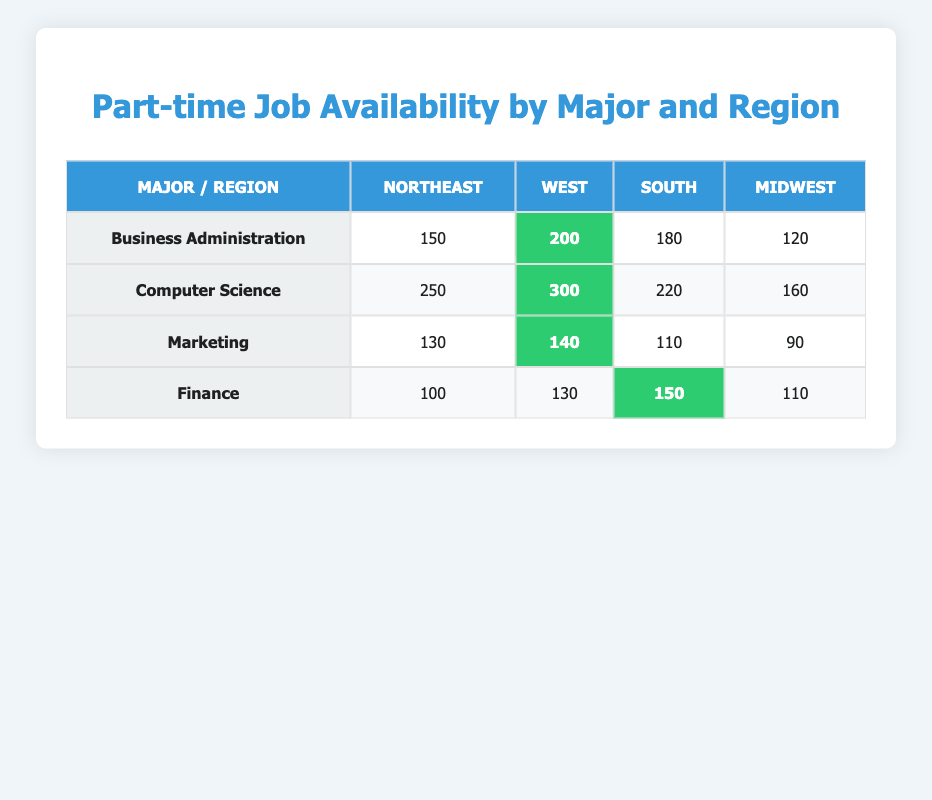What is the number of part-time jobs available for Business Administration students in the West region? The table shows that for Business Administration students in the West region, the number of part-time jobs available is highlighted as 200.
Answer: 200 Which major has the highest availability of part-time jobs in the Northeast region? By examining the Northeast column, Computer Science has the highest number of part-time jobs available, with a total of 250 jobs compared to 150 for Business Administration, 130 for Marketing, and 100 for Finance.
Answer: Computer Science What is the total number of part-time jobs available for Marketing students across all regions? The total can be calculated as follows: Northeast (130) + West (140) + South (110) + Midwest (90) = 130 + 140 + 110 + 90 = 470.
Answer: 470 Are there more part-time jobs available for Finance students in the South region compared to those in the Midwest region? The table indicates that there are 150 part-time jobs available for Finance students in the South region and 110 in the Midwest region. Since 150 is greater than 110, the answer is yes.
Answer: Yes What is the difference in availability of part-time jobs between Computer Science and Business Administration students in the West region? For Computer Science students, there are 300 part-time jobs available while for Business Administration students, there are 200. The difference is calculated as 300 - 200 = 100.
Answer: 100 Which region has the lowest availability of part-time jobs for Marketing students? By looking at the Marketing row, the Midwest region has the lowest availability with only 90 part-time jobs, compared to 130 in the Northeast, 140 in the West, and 110 in the South.
Answer: Midwest Which major has the least number of part-time jobs available overall? To find the least number, we need to sum the part-time jobs for each major: Business Administration (150 + 200 + 180 + 120 = 650), Computer Science (250 + 300 + 220 + 160 = 930), Marketing (130 + 140 + 110 + 90 = 470), and Finance (100 + 130 + 150 + 110 = 490). The lowest total is for Marketing with 470.
Answer: Marketing Is the number of part-time jobs available for Computer Science students in the South region greater than that for Finance students in the Northeast region? The table indicates there are 220 part-time jobs for Computer Science in the South and 100 for Finance in the Northeast. Since 220 is greater than 100, the answer is yes.
Answer: Yes 